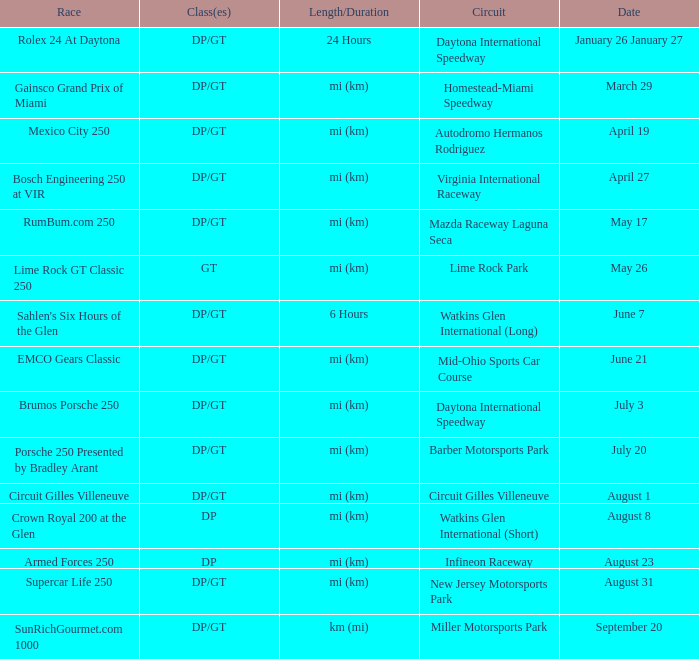How long and how much time does the race on april 19 take? Mi (km). Help me parse the entirety of this table. {'header': ['Race', 'Class(es)', 'Length/Duration', 'Circuit', 'Date'], 'rows': [['Rolex 24 At Daytona', 'DP/GT', '24 Hours', 'Daytona International Speedway', 'January 26 January 27'], ['Gainsco Grand Prix of Miami', 'DP/GT', 'mi (km)', 'Homestead-Miami Speedway', 'March 29'], ['Mexico City 250', 'DP/GT', 'mi (km)', 'Autodromo Hermanos Rodriguez', 'April 19'], ['Bosch Engineering 250 at VIR', 'DP/GT', 'mi (km)', 'Virginia International Raceway', 'April 27'], ['RumBum.com 250', 'DP/GT', 'mi (km)', 'Mazda Raceway Laguna Seca', 'May 17'], ['Lime Rock GT Classic 250', 'GT', 'mi (km)', 'Lime Rock Park', 'May 26'], ["Sahlen's Six Hours of the Glen", 'DP/GT', '6 Hours', 'Watkins Glen International (Long)', 'June 7'], ['EMCO Gears Classic', 'DP/GT', 'mi (km)', 'Mid-Ohio Sports Car Course', 'June 21'], ['Brumos Porsche 250', 'DP/GT', 'mi (km)', 'Daytona International Speedway', 'July 3'], ['Porsche 250 Presented by Bradley Arant', 'DP/GT', 'mi (km)', 'Barber Motorsports Park', 'July 20'], ['Circuit Gilles Villeneuve', 'DP/GT', 'mi (km)', 'Circuit Gilles Villeneuve', 'August 1'], ['Crown Royal 200 at the Glen', 'DP', 'mi (km)', 'Watkins Glen International (Short)', 'August 8'], ['Armed Forces 250', 'DP', 'mi (km)', 'Infineon Raceway', 'August 23'], ['Supercar Life 250', 'DP/GT', 'mi (km)', 'New Jersey Motorsports Park', 'August 31'], ['SunRichGourmet.com 1000', 'DP/GT', 'km (mi)', 'Miller Motorsports Park', 'September 20']]} 